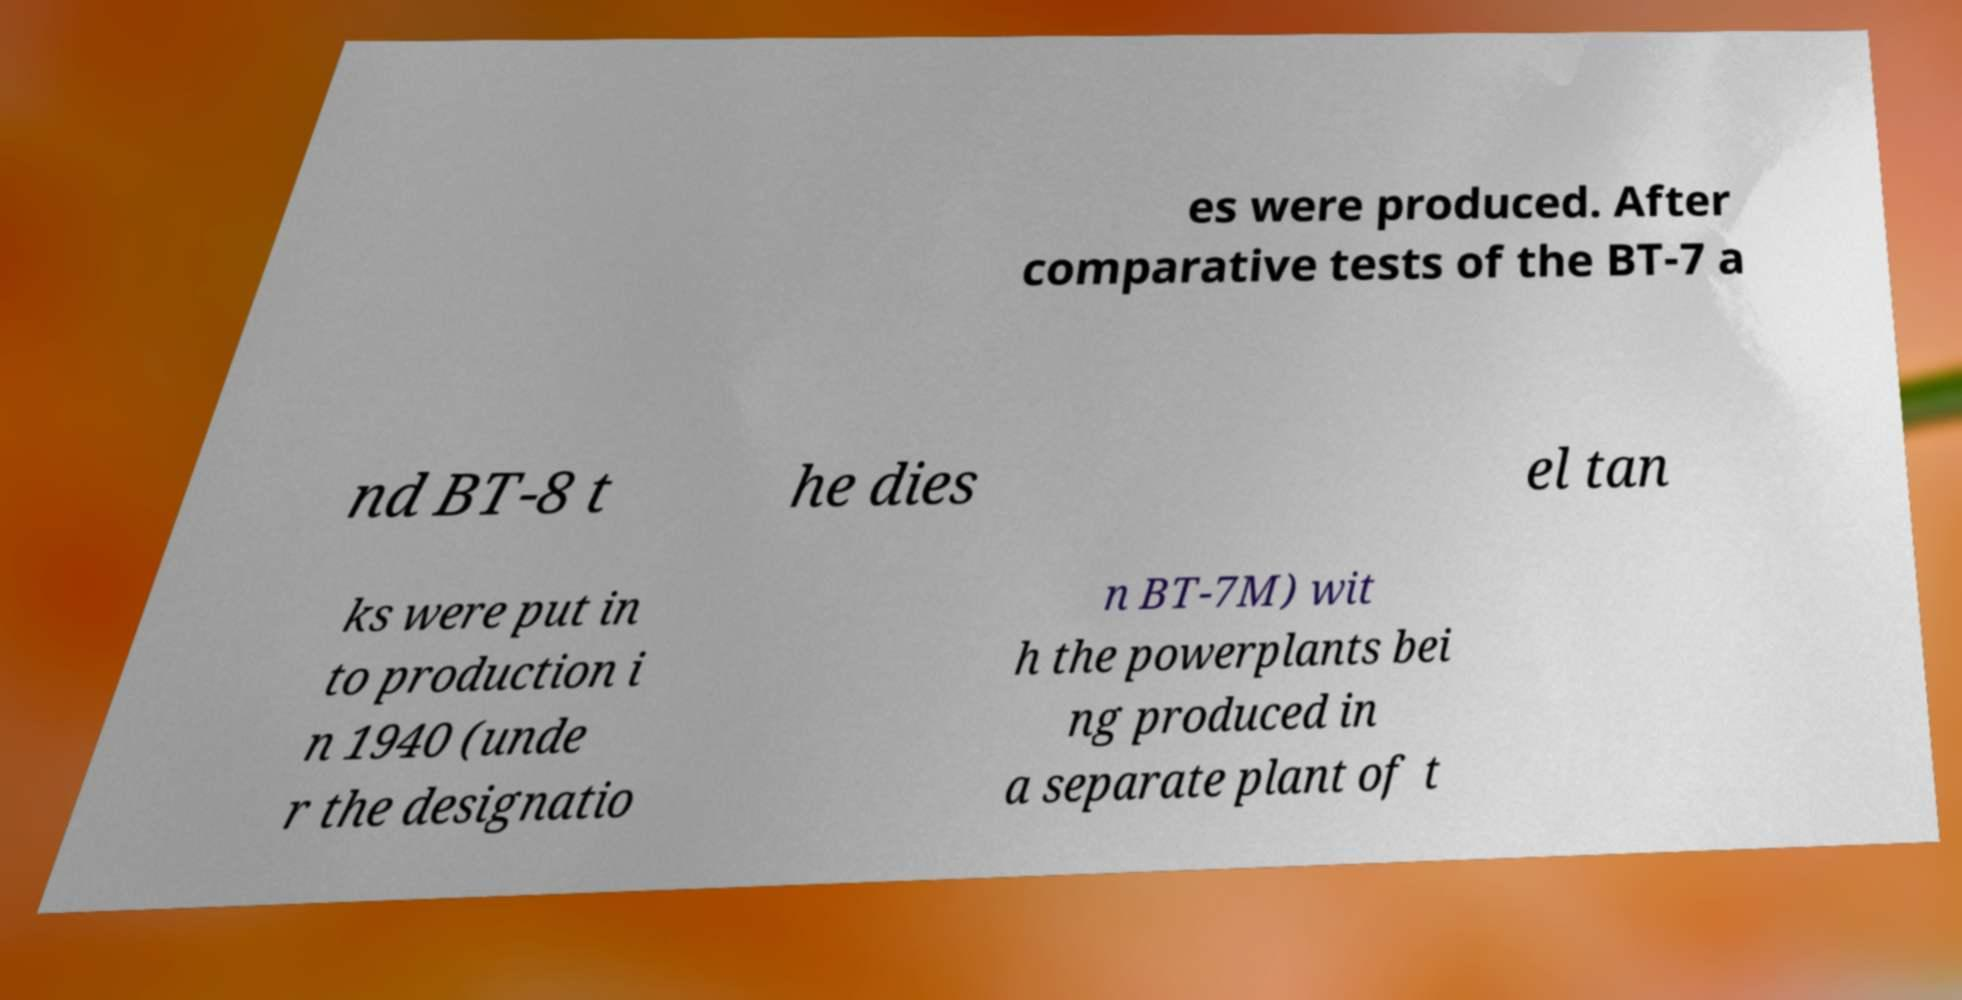For documentation purposes, I need the text within this image transcribed. Could you provide that? es were produced. After comparative tests of the BT-7 a nd BT-8 t he dies el tan ks were put in to production i n 1940 (unde r the designatio n BT-7M) wit h the powerplants bei ng produced in a separate plant of t 